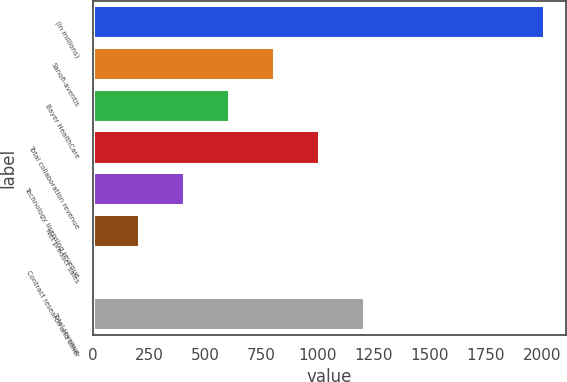Convert chart. <chart><loc_0><loc_0><loc_500><loc_500><bar_chart><fcel>(In millions)<fcel>Sanofi-aventis<fcel>Bayer HealthCare<fcel>Total collaboration revenue<fcel>Technology licensing revenue<fcel>Net product sales<fcel>Contract research and other<fcel>Total revenue<nl><fcel>2009<fcel>807.44<fcel>607.18<fcel>1007.7<fcel>406.92<fcel>206.66<fcel>6.4<fcel>1207.96<nl></chart> 